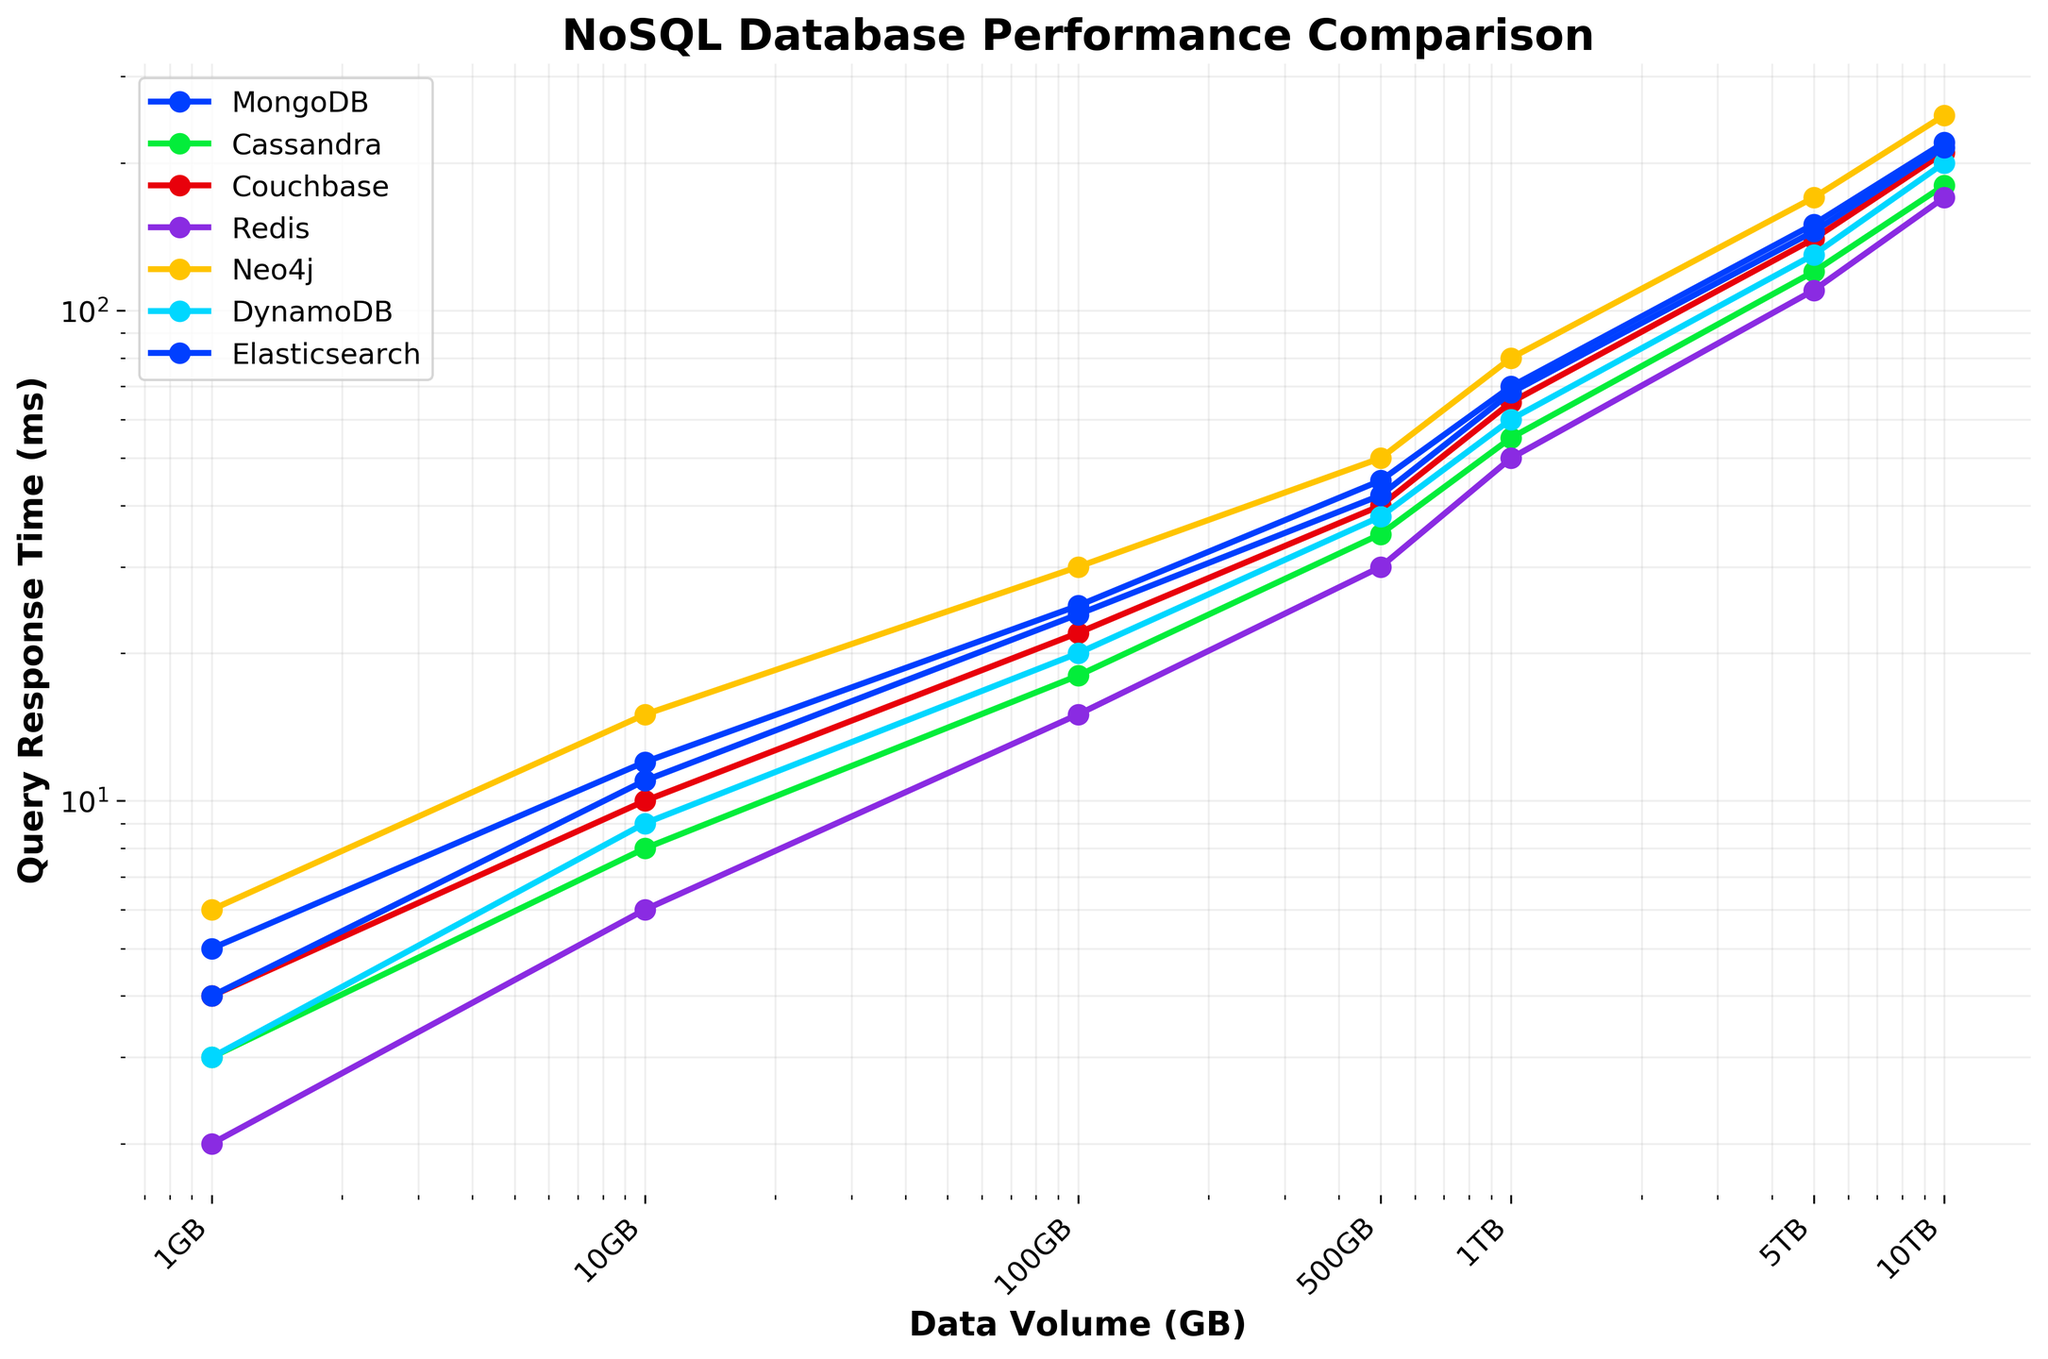What is the query response time for MongoDB when the data volume is 1TB? To find the query response time for MongoDB at 1TB, look at the plotted data for MongoDB and locate the corresponding value on the y-axis aligned with 1TB (1000GB) on the x-axis.
Answer: 70 ms Which database has the smallest query response time at 5TB? Compare the y-axis values for all databases at the 5TB mark on the x-axis. The database with the smallest value is Redis with 110 ms.
Answer: Redis By how much does the query response time for Cassandra increase from 1GB to 500GB? Find the query response times for Cassandra at 1GB and 500GB. Subtract the 1GB response time (3 ms) from the 500GB response time (35 ms).
Answer: 32 ms Which two databases have nearly similar response times at 10TB, and what are these times? Check the y-axis for the data points at 10TB for all the databases and identify the ones with closely similar values. Couchbase and Elasticsearch have response times of 210 ms and 215 ms, respectively.
Answer: Couchbase (210 ms) and Elasticsearch (215 ms) What’s the average query response time for DynamoDB over all data volumes? Add the response times of DynamoDB across all the data volumes and divide by the number of data points (7): (3+9+20+38+60+130+200) / 7.
Answer: 460 / 7 ≈ 65.71 ms Between MongoDB and Neo4j, which one shows a steeper increase in response time as the data volume grows from 1GB to 10TB? Compare the slopes of the lines for MongoDB and Neo4j from 1GB to 10TB. MongoDB goes from 5 ms to 220 ms, an increase of 215 ms, while Neo4j goes from 6 ms to 250 ms, an increase of 244 ms. Neo4j shows a steeper increase.
Answer: Neo4j By what factor does the query response time for Redis increase from 1GB to 1TB? Divide the query response time for Redis at 1TB by the time at 1GB: 50 ms / 2 ms.
Answer: 25 Which database has the largest variance in its query response times across the different data volumes? Calculate the variance for each database's query response times. Neo4j has the largest range from 6 ms to 250 ms, indicating it likely has the largest variance.
Answer: Neo4j What’s the combined response time for Couchbase and Redis at 500GB? Sum the response times of Couchbase and Redis at 500GB. Couchbase is 40 ms and Redis is 30 ms.
Answer: 70 ms 